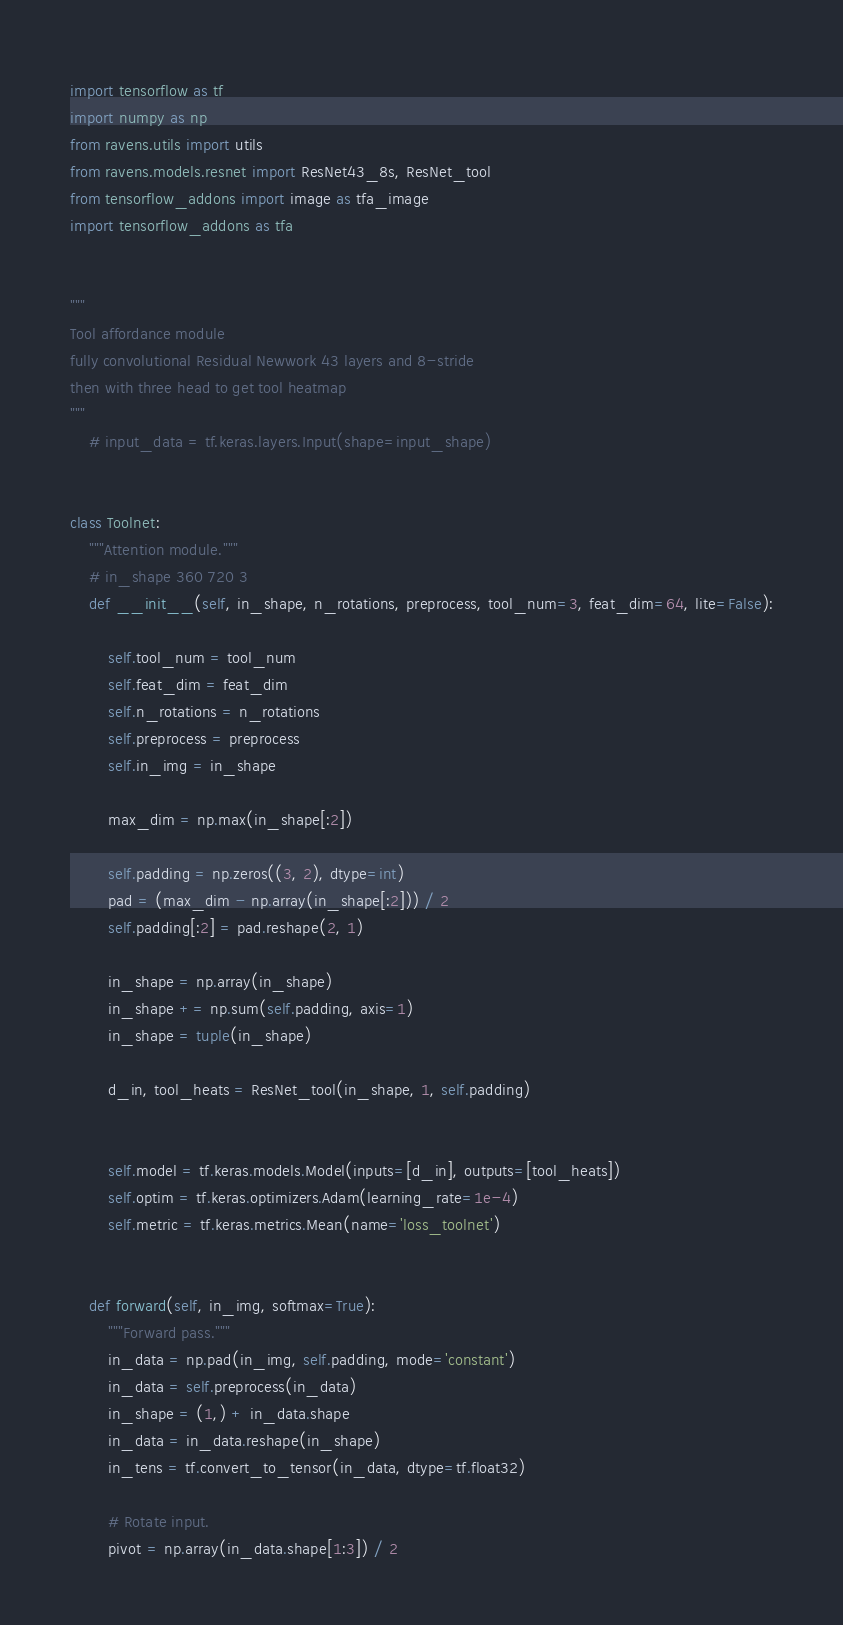Convert code to text. <code><loc_0><loc_0><loc_500><loc_500><_Python_>import tensorflow as tf
import numpy as np
from ravens.utils import utils
from ravens.models.resnet import ResNet43_8s, ResNet_tool
from tensorflow_addons import image as tfa_image
import tensorflow_addons as tfa


"""
Tool affordance module
fully convolutional Residual Newwork 43 layers and 8-stride
then with three head to get tool heatmap
"""
	# input_data = tf.keras.layers.Input(shape=input_shape)


class Toolnet:
	"""Attention module."""
	# in_shape 360 720 3
	def __init__(self, in_shape, n_rotations, preprocess, tool_num=3, feat_dim=64, lite=False):

		self.tool_num = tool_num
		self.feat_dim = feat_dim
		self.n_rotations = n_rotations
		self.preprocess = preprocess
		self.in_img = in_shape

		max_dim = np.max(in_shape[:2])

		self.padding = np.zeros((3, 2), dtype=int)
		pad = (max_dim - np.array(in_shape[:2])) / 2
		self.padding[:2] = pad.reshape(2, 1)

		in_shape = np.array(in_shape)
		in_shape += np.sum(self.padding, axis=1)
		in_shape = tuple(in_shape)

		d_in, tool_heats = ResNet_tool(in_shape, 1, self.padding)


		self.model = tf.keras.models.Model(inputs=[d_in], outputs=[tool_heats])
		self.optim = tf.keras.optimizers.Adam(learning_rate=1e-4)
		self.metric = tf.keras.metrics.Mean(name='loss_toolnet')


	def forward(self, in_img, softmax=True):
		"""Forward pass."""
		in_data = np.pad(in_img, self.padding, mode='constant')
		in_data = self.preprocess(in_data)
		in_shape = (1,) + in_data.shape
		in_data = in_data.reshape(in_shape)
		in_tens = tf.convert_to_tensor(in_data, dtype=tf.float32)

		# Rotate input.
		pivot = np.array(in_data.shape[1:3]) / 2</code> 